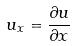<formula> <loc_0><loc_0><loc_500><loc_500>u _ { x } = \frac { \partial u } { \partial x }</formula> 